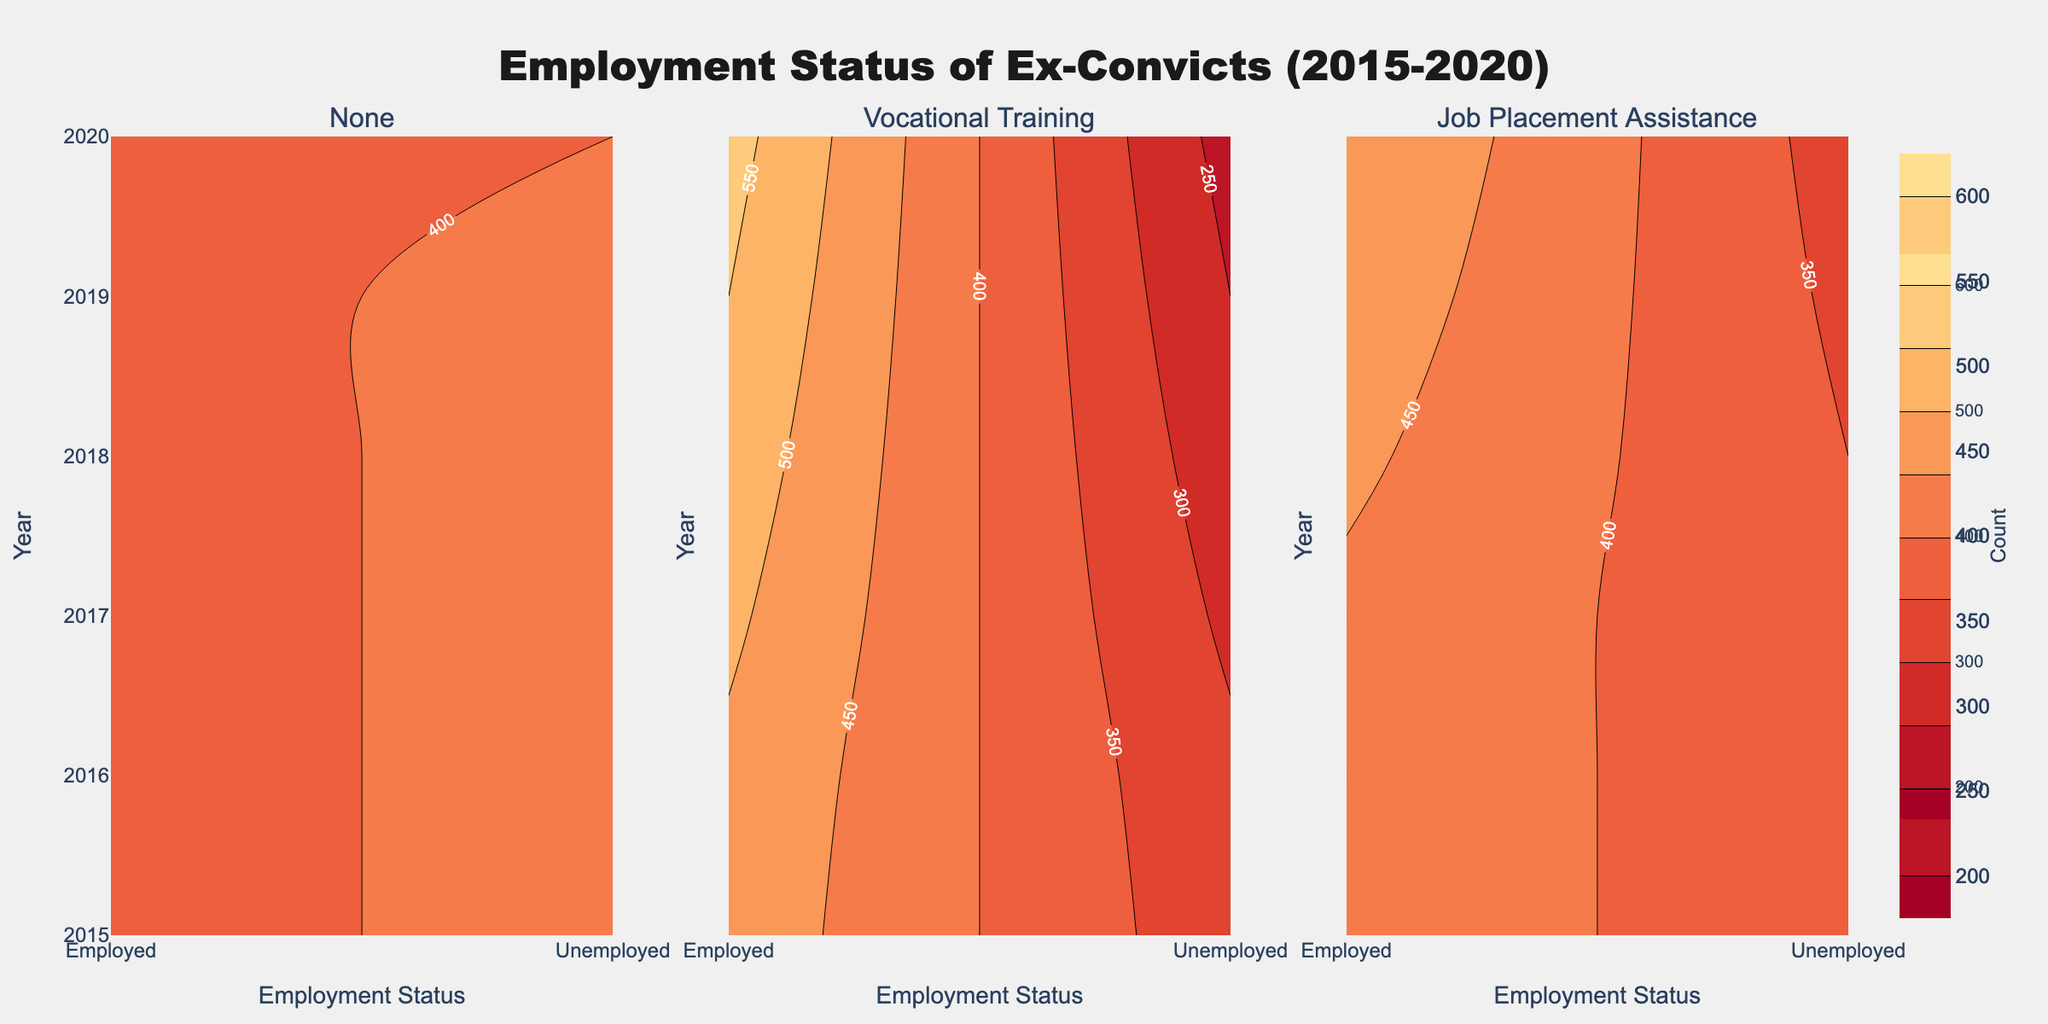What is the title of the figure? The title is located at the top center of the figure, which states the main focus of the data presented. It is written in a larger, bolder font to stand out.
Answer: Employment Status of Ex-Convicts (2015-2020) Which employment status had a higher count in 2018 for those who participated in Job Placement Assistance? Looking at the subplot for Job Placement Assistance in 2018, compare the contours at the "Employed" and "Unemployed" labels on the x-axis.
Answer: Employed How did the count of employed ex-convicts change from 2015 to 2020 for those with no state support program? Look at the contour line for "Employed" on the subplot titled "None." Follow the year labels from 2015 to 2020 and observe how the count changes for "Employed."
Answer: Increased Which state support program had the highest count of employed ex-convicts in 2020? Compare the contours at the label "Employed" on the different subplots (None, Vocational Training, Job Placement Assistance) for the year 2020.
Answer: Vocational Training What is the trend in unemployment counts for those with Vocational Training from 2015 to 2020? Follow the contour line for "Unemployed" in the subplot titled "Vocational Training." Observe if the counts are increasing or decreasing over the years from 2015 to 2020.
Answer: Decreasing Which employment status had a lower count in 2017 for high school graduates with no state support programs? Check the contour lines in the subplot titled "None" for the year 2017 and compare the counts for "Employed" and "Unemployed."
Answer: Employed How does the employment status distribution for 2016 compare between Vocational Training and Job Placement Assistance programs? Look at the contours for both "Employed" and "Unemployed" for 2016 across the subplots for Vocational Training and Job Placement Assistance. Compare the values seen on the contour lines.
Answer: Higher in Vocational Training What are the dominant colors used in the contours, and what do they indicate? Observe the colors used in the contour plots, focusing on the main colors and their gradients. These colors are indicated in the color scale to represent different ranges of counts.
Answer: Shades of red and orange represent count range from 200 to 600 Which program appears to have the most stable employment status over the years, based on the contour lines? Compare the contour lines for the "Employed" status for all three state support programs. The program with less fluctuation in the contour lines over the years is the most stable.
Answer: Job Placement Assistance 